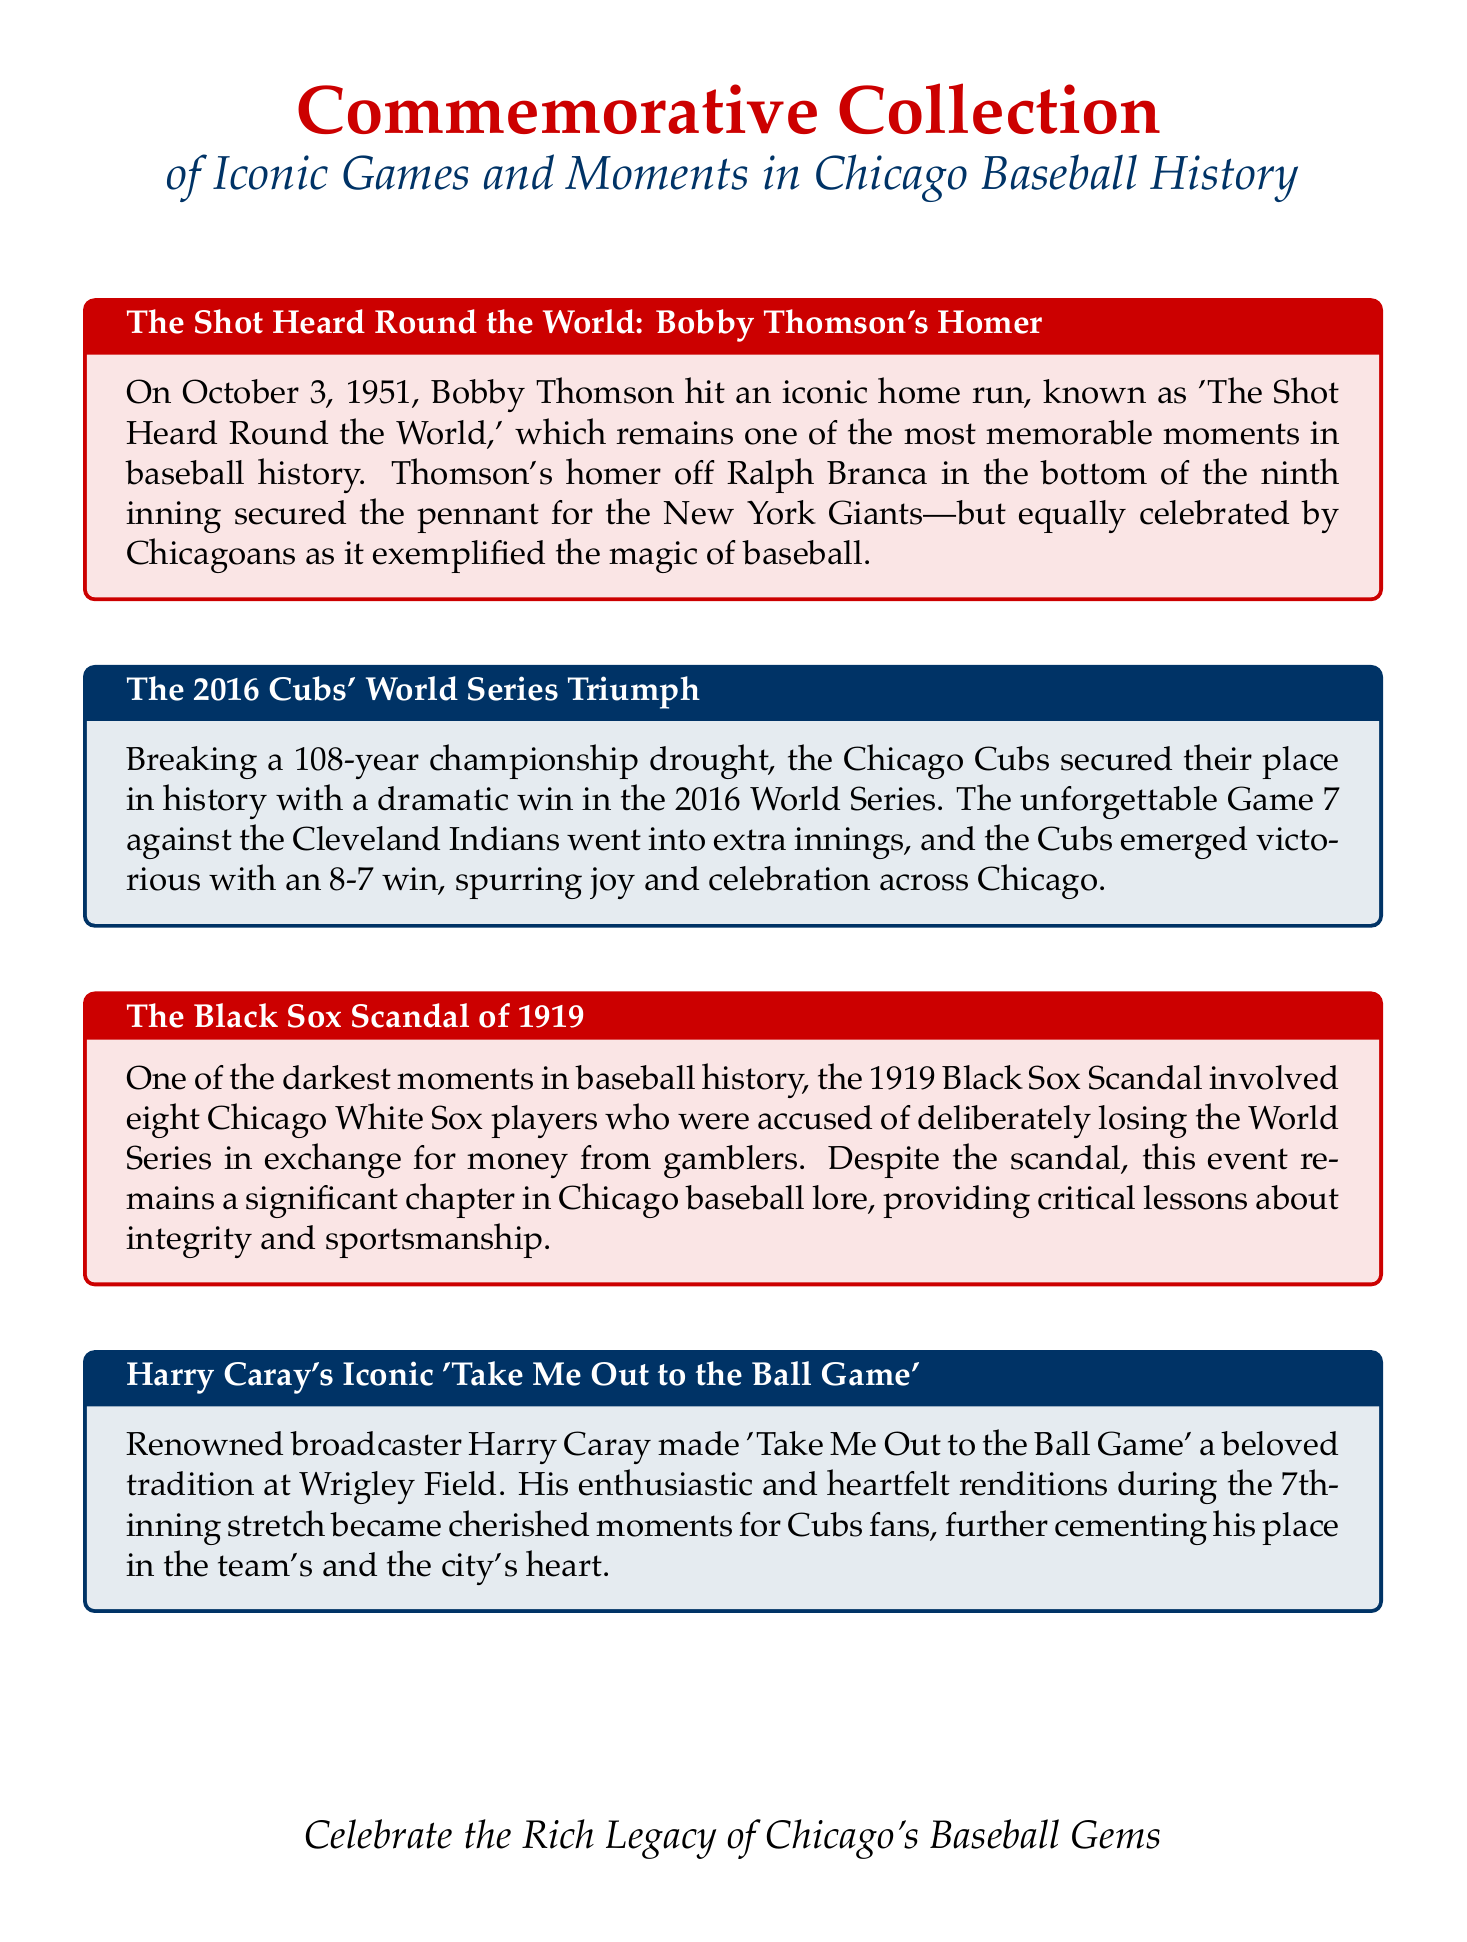What is the title of the document? The title of the document is prominently displayed at the top, indicating its central theme.
Answer: Commemorative Collection What year did the Cubs break their championship drought? The document provides the specific year when the Cubs succeeded in winning the World Series after a long wait.
Answer: 2016 Who hit 'The Shot Heard Round the World'? This question asks for the key player behind one of the most memorable baseball moments highlighted in the document.
Answer: Bobby Thomson What scandal is associated with the Chicago White Sox? The document mentions a specific scandal that involved the Chicago White Sox and had significant implications for baseball history.
Answer: Black Sox Scandal How long was the Cubs' championship drought? The document notes the duration of time the Cubs went without winning a championship until 2016.
Answer: 108 years What song did Harry Caray popularize during games? The document highlights a specific song that became a beloved tradition at Wrigley Field thanks to a famous broadcaster.
Answer: Take Me Out to the Ball Game What was the final score of the 2016 Cubs' World Series Game 7? The document specifies the score of the pivotal game in which the Cubs secured their long-awaited victory.
Answer: 8-7 In which inning does 'Take Me Out to the Ball Game' typically occur? The document mentions the specific inning during which this beloved tradition is performed at Wrigley Field.
Answer: 7th inning What date did Bobby Thomson hit his famous home run? The document states the exact date when one of baseball's iconic moments took place.
Answer: October 3, 1951 